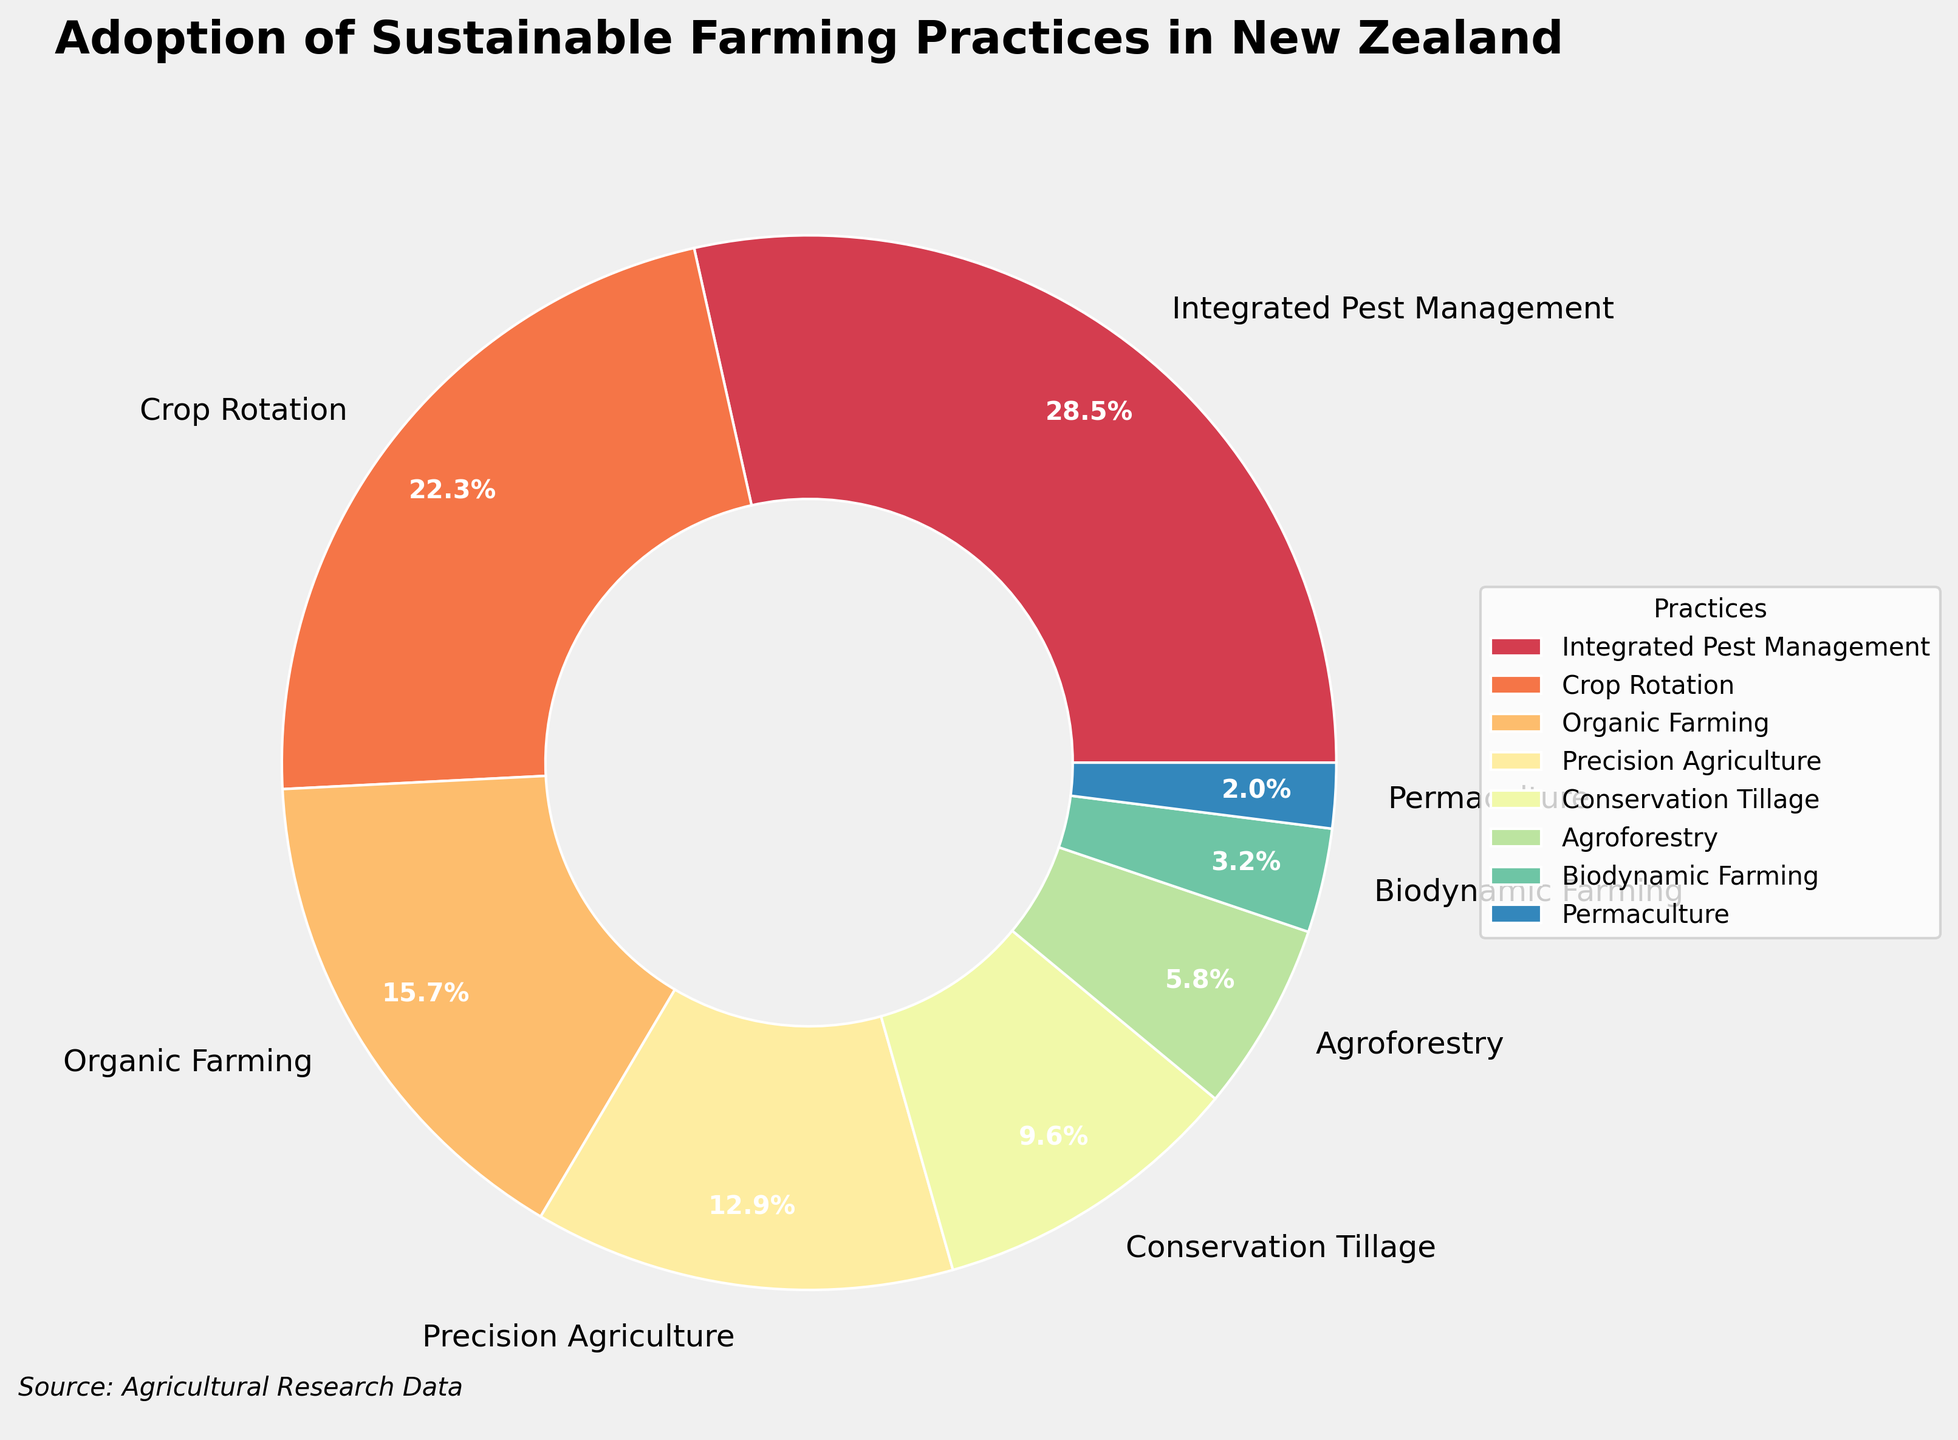Which sustainable farming practice has the highest adoption rate? The chart shows the proportions of different sustainable farming practices. The largest segment of the pie chart corresponds to Integrated Pest Management, which is labeled with 28.5%.
Answer: Integrated Pest Management Which sustainable farming practice has the lowest adoption rate? The chart shows the smallest segment of the pie chart corresponds to Permaculture, which is labeled with 2.0%.
Answer: Permaculture What is the combined adoption rate of Crop Rotation, Organic Farming, and Precision Agriculture? To find the combined adoption rate, sum the percentages for Crop Rotation (22.3%), Organic Farming (15.7%), and Precision Agriculture (12.9%). The calculation is 22.3 + 15.7 + 12.9 = 50.9%.
Answer: 50.9% How much more popular is Integrated Pest Management compared to Conservation Tillage? To determine how much more popular Integrated Pest Management (28.5%) is compared to Conservation Tillage (9.6%), subtract Conservation Tillage's rate from Integrated Pest Management's. The calculation is 28.5 - 9.6 = 18.9%.
Answer: 18.9% Which practice is more adopted: Agroforestry or Biodynamic Farming, and by how much? By examining the chart, Agroforestry has an adoption rate of 5.8% and Biodynamic Farming has 3.2%. Subtract Biodynamic Farming's rate from Agroforestry's. The calculation is 5.8 - 3.2 = 2.6%.
Answer: Agroforestry by 2.6% What percentage of farmers adopt practices other than Integrated Pest Management? To find the percentage of farmers adopting practices other than Integrated Pest Management, subtract Integrated Pest Management's rate from 100%. The calculation is 100 - 28.5 = 71.5%.
Answer: 71.5% What is the adoption rate difference between the top two practices? The top two practices are Integrated Pest Management (28.5%) and Crop Rotation (22.3%). To find the difference, subtract Crop Rotation's rate from Integrated Pest Management's. The calculation is 28.5 - 22.3 = 6.2%.
Answer: 6.2% Is the adoption rate of Permaculture closer to the rate of Biodynamic Farming or Conservation Tillage? The adoption rate of Permaculture is 2.0%, Biodynamic Farming is 3.2%, and Conservation Tillage is 9.6%. Calculate the differences: 3.2 - 2.0 = 1.2% (for Biodynamic Farming) and 9.6 - 2.0 = 7.6% (for Conservation Tillage). The smaller difference is with Biodynamic Farming.
Answer: Biodynamic Farming What proportion of farmers adopt either Organic Farming or Precision Agriculture? To find this proportion, add the adoption rates of Organic Farming (15.7%) and Precision Agriculture (12.9%). The calculation is 15.7 + 12.9 = 28.6%.
Answer: 28.6% How much more common is Organic Farming compared to Biodynamic Farming? The chart shows that Organic Farming has an adoption rate of 15.7% and Biodynamic Farming has 3.2%. Subtract Biodynamic Farming's rate from Organic Farming's. The calculation is 15.7 - 3.2 = 12.5%.
Answer: 12.5% 